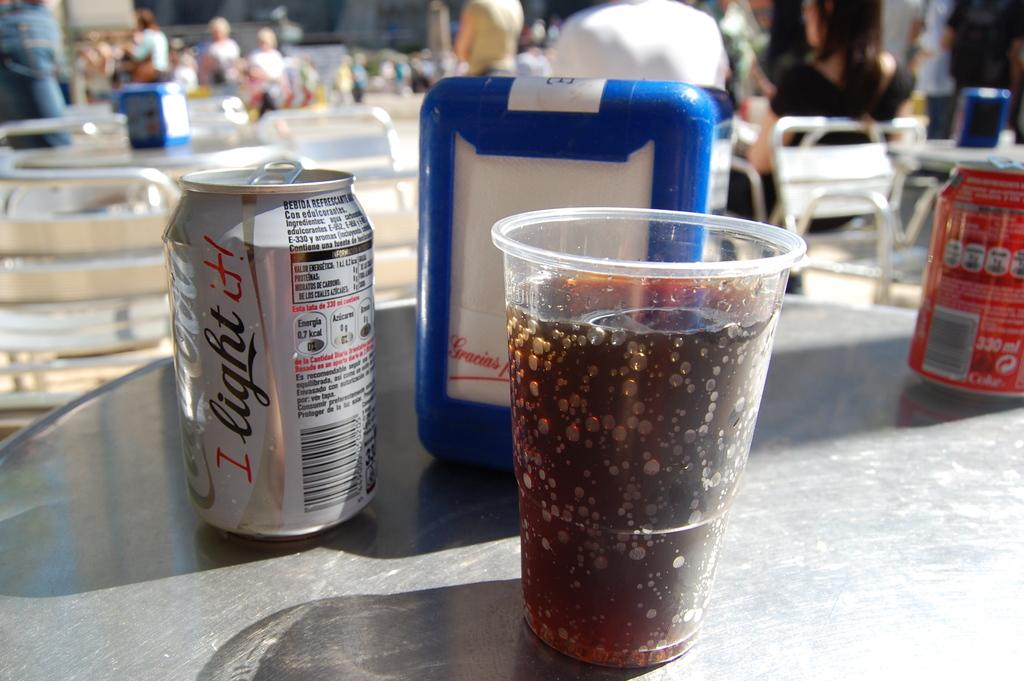<image>
Render a clear and concise summary of the photo. A silver can of Coca-Cola light sitting on a table. 